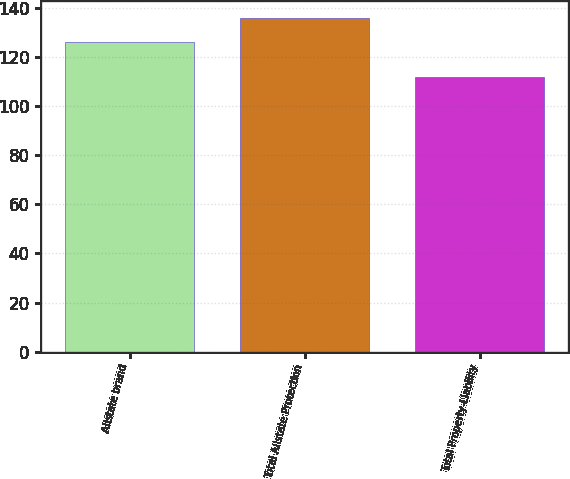Convert chart. <chart><loc_0><loc_0><loc_500><loc_500><bar_chart><fcel>Allstate brand<fcel>Total Allstate Protection<fcel>Total Property-Liability<nl><fcel>126<fcel>136<fcel>112<nl></chart> 